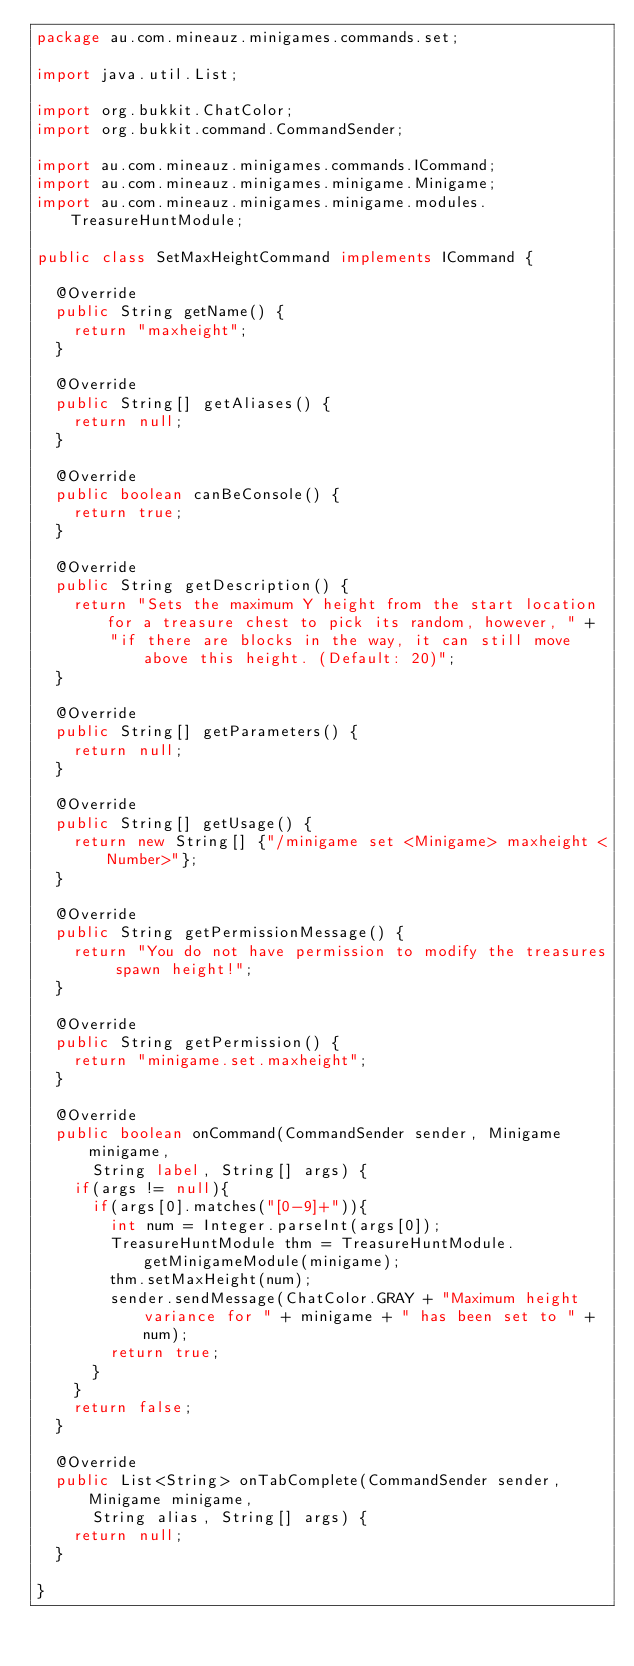<code> <loc_0><loc_0><loc_500><loc_500><_Java_>package au.com.mineauz.minigames.commands.set;

import java.util.List;

import org.bukkit.ChatColor;
import org.bukkit.command.CommandSender;

import au.com.mineauz.minigames.commands.ICommand;
import au.com.mineauz.minigames.minigame.Minigame;
import au.com.mineauz.minigames.minigame.modules.TreasureHuntModule;

public class SetMaxHeightCommand implements ICommand {

	@Override
	public String getName() {
		return "maxheight";
	}

	@Override
	public String[] getAliases() {
		return null;
	}

	@Override
	public boolean canBeConsole() {
		return true;
	}

	@Override
	public String getDescription() {
		return "Sets the maximum Y height from the start location for a treasure chest to pick its random, however, " +
				"if there are blocks in the way, it can still move above this height. (Default: 20)";
	}

	@Override
	public String[] getParameters() {
		return null;
	}

	@Override
	public String[] getUsage() {
		return new String[] {"/minigame set <Minigame> maxheight <Number>"};
	}

	@Override
	public String getPermissionMessage() {
		return "You do not have permission to modify the treasures spawn height!";
	}

	@Override
	public String getPermission() {
		return "minigame.set.maxheight";
	}

	@Override
	public boolean onCommand(CommandSender sender, Minigame minigame,
			String label, String[] args) {
		if(args != null){
			if(args[0].matches("[0-9]+")){
				int num = Integer.parseInt(args[0]);
				TreasureHuntModule thm = TreasureHuntModule.getMinigameModule(minigame);
				thm.setMaxHeight(num);
				sender.sendMessage(ChatColor.GRAY + "Maximum height variance for " + minigame + " has been set to " + num);
				return true;
			}
		}
		return false;
	}

	@Override
	public List<String> onTabComplete(CommandSender sender, Minigame minigame,
			String alias, String[] args) {
		return null;
	}

}
</code> 